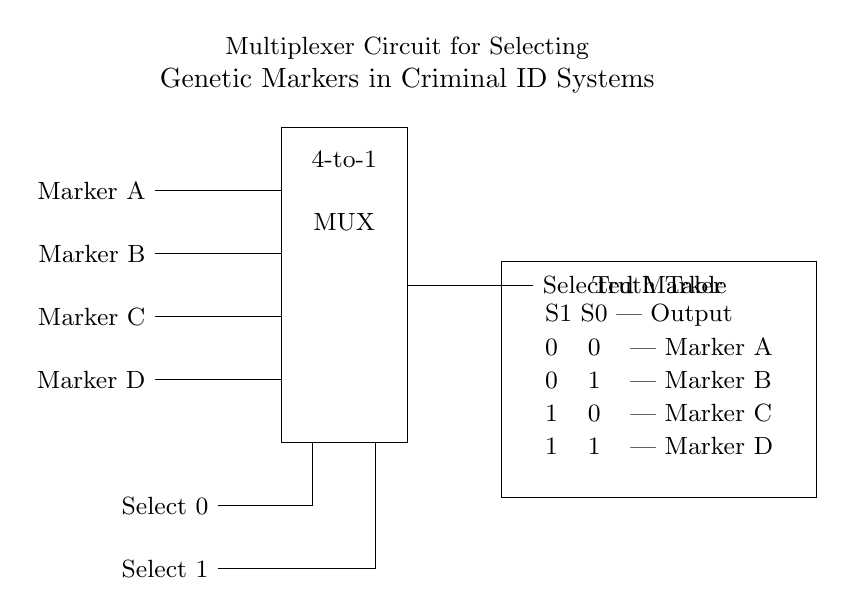What type of circuit is shown? The circuit diagram depicts a multiplexer, which is specifically a 4-to-1 multiplexer as indicated in the drawing.
Answer: Multiplexer How many input markers are present? The diagram shows four input markers labeled A, B, C, and D, which are connected to the multiplexer.
Answer: Four What do the select lines control? The select lines, labeled Select 0 and Select 1, determine which input marker (A, B, C, or D) will be sent to the output, based on their binary combination.
Answer: Output selection What is the output when both select lines are low? According to the truth table, when both select lines S1 and S0 are low (0 0), the output is Marker A.
Answer: Marker A How does the truth table relate to the multiplexer operation? The truth table provides a mapping of the select line combinations (S1, S0) to specific outputs. For instance, the first row corresponds to when both select lines are low, leading to the selection of Marker A.
Answer: It shows select-output mapping What is the function of the rectangle in the circuit? The rectangle represents the multiplexer, which processes the inputs and outputs one of the selected markers based on the state of the select lines.
Answer: Represents MUX 